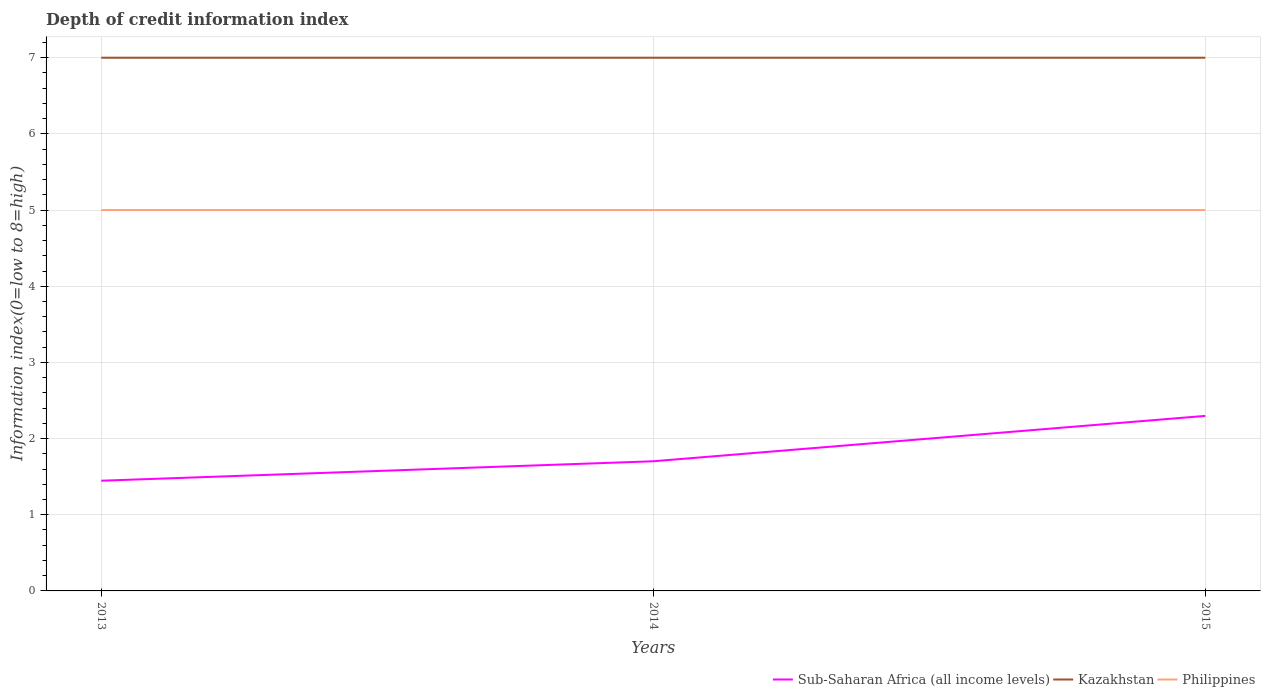How many different coloured lines are there?
Make the answer very short. 3. Does the line corresponding to Kazakhstan intersect with the line corresponding to Sub-Saharan Africa (all income levels)?
Provide a short and direct response. No. Is the number of lines equal to the number of legend labels?
Give a very brief answer. Yes. Across all years, what is the maximum information index in Philippines?
Your answer should be very brief. 5. In which year was the information index in Kazakhstan maximum?
Your answer should be compact. 2013. What is the difference between the highest and the second highest information index in Philippines?
Your answer should be very brief. 0. What is the difference between the highest and the lowest information index in Sub-Saharan Africa (all income levels)?
Your answer should be very brief. 1. What is the difference between two consecutive major ticks on the Y-axis?
Provide a short and direct response. 1. Does the graph contain any zero values?
Offer a terse response. No. Does the graph contain grids?
Give a very brief answer. Yes. What is the title of the graph?
Offer a terse response. Depth of credit information index. What is the label or title of the Y-axis?
Offer a very short reply. Information index(0=low to 8=high). What is the Information index(0=low to 8=high) of Sub-Saharan Africa (all income levels) in 2013?
Give a very brief answer. 1.45. What is the Information index(0=low to 8=high) of Kazakhstan in 2013?
Your answer should be compact. 7. What is the Information index(0=low to 8=high) of Sub-Saharan Africa (all income levels) in 2014?
Ensure brevity in your answer.  1.7. What is the Information index(0=low to 8=high) in Sub-Saharan Africa (all income levels) in 2015?
Make the answer very short. 2.3. What is the Information index(0=low to 8=high) in Kazakhstan in 2015?
Make the answer very short. 7. Across all years, what is the maximum Information index(0=low to 8=high) of Sub-Saharan Africa (all income levels)?
Make the answer very short. 2.3. Across all years, what is the maximum Information index(0=low to 8=high) of Kazakhstan?
Your response must be concise. 7. Across all years, what is the maximum Information index(0=low to 8=high) of Philippines?
Provide a short and direct response. 5. Across all years, what is the minimum Information index(0=low to 8=high) in Sub-Saharan Africa (all income levels)?
Offer a very short reply. 1.45. Across all years, what is the minimum Information index(0=low to 8=high) of Kazakhstan?
Keep it short and to the point. 7. Across all years, what is the minimum Information index(0=low to 8=high) of Philippines?
Your answer should be very brief. 5. What is the total Information index(0=low to 8=high) of Sub-Saharan Africa (all income levels) in the graph?
Ensure brevity in your answer.  5.45. What is the total Information index(0=low to 8=high) in Philippines in the graph?
Ensure brevity in your answer.  15. What is the difference between the Information index(0=low to 8=high) of Sub-Saharan Africa (all income levels) in 2013 and that in 2014?
Offer a terse response. -0.26. What is the difference between the Information index(0=low to 8=high) in Kazakhstan in 2013 and that in 2014?
Your answer should be very brief. 0. What is the difference between the Information index(0=low to 8=high) of Philippines in 2013 and that in 2014?
Your answer should be very brief. 0. What is the difference between the Information index(0=low to 8=high) of Sub-Saharan Africa (all income levels) in 2013 and that in 2015?
Ensure brevity in your answer.  -0.85. What is the difference between the Information index(0=low to 8=high) of Sub-Saharan Africa (all income levels) in 2014 and that in 2015?
Ensure brevity in your answer.  -0.6. What is the difference between the Information index(0=low to 8=high) in Philippines in 2014 and that in 2015?
Your response must be concise. 0. What is the difference between the Information index(0=low to 8=high) in Sub-Saharan Africa (all income levels) in 2013 and the Information index(0=low to 8=high) in Kazakhstan in 2014?
Provide a short and direct response. -5.55. What is the difference between the Information index(0=low to 8=high) of Sub-Saharan Africa (all income levels) in 2013 and the Information index(0=low to 8=high) of Philippines in 2014?
Your answer should be compact. -3.55. What is the difference between the Information index(0=low to 8=high) of Sub-Saharan Africa (all income levels) in 2013 and the Information index(0=low to 8=high) of Kazakhstan in 2015?
Keep it short and to the point. -5.55. What is the difference between the Information index(0=low to 8=high) of Sub-Saharan Africa (all income levels) in 2013 and the Information index(0=low to 8=high) of Philippines in 2015?
Offer a terse response. -3.55. What is the difference between the Information index(0=low to 8=high) in Kazakhstan in 2013 and the Information index(0=low to 8=high) in Philippines in 2015?
Provide a short and direct response. 2. What is the difference between the Information index(0=low to 8=high) of Sub-Saharan Africa (all income levels) in 2014 and the Information index(0=low to 8=high) of Kazakhstan in 2015?
Your answer should be compact. -5.3. What is the difference between the Information index(0=low to 8=high) of Sub-Saharan Africa (all income levels) in 2014 and the Information index(0=low to 8=high) of Philippines in 2015?
Make the answer very short. -3.3. What is the difference between the Information index(0=low to 8=high) in Kazakhstan in 2014 and the Information index(0=low to 8=high) in Philippines in 2015?
Your response must be concise. 2. What is the average Information index(0=low to 8=high) of Sub-Saharan Africa (all income levels) per year?
Make the answer very short. 1.82. What is the average Information index(0=low to 8=high) in Kazakhstan per year?
Give a very brief answer. 7. In the year 2013, what is the difference between the Information index(0=low to 8=high) of Sub-Saharan Africa (all income levels) and Information index(0=low to 8=high) of Kazakhstan?
Provide a succinct answer. -5.55. In the year 2013, what is the difference between the Information index(0=low to 8=high) of Sub-Saharan Africa (all income levels) and Information index(0=low to 8=high) of Philippines?
Provide a succinct answer. -3.55. In the year 2014, what is the difference between the Information index(0=low to 8=high) of Sub-Saharan Africa (all income levels) and Information index(0=low to 8=high) of Kazakhstan?
Give a very brief answer. -5.3. In the year 2014, what is the difference between the Information index(0=low to 8=high) in Sub-Saharan Africa (all income levels) and Information index(0=low to 8=high) in Philippines?
Ensure brevity in your answer.  -3.3. In the year 2014, what is the difference between the Information index(0=low to 8=high) in Kazakhstan and Information index(0=low to 8=high) in Philippines?
Provide a short and direct response. 2. In the year 2015, what is the difference between the Information index(0=low to 8=high) in Sub-Saharan Africa (all income levels) and Information index(0=low to 8=high) in Kazakhstan?
Provide a succinct answer. -4.7. In the year 2015, what is the difference between the Information index(0=low to 8=high) of Sub-Saharan Africa (all income levels) and Information index(0=low to 8=high) of Philippines?
Provide a succinct answer. -2.7. In the year 2015, what is the difference between the Information index(0=low to 8=high) of Kazakhstan and Information index(0=low to 8=high) of Philippines?
Make the answer very short. 2. What is the ratio of the Information index(0=low to 8=high) of Sub-Saharan Africa (all income levels) in 2013 to that in 2014?
Your answer should be very brief. 0.85. What is the ratio of the Information index(0=low to 8=high) in Kazakhstan in 2013 to that in 2014?
Offer a very short reply. 1. What is the ratio of the Information index(0=low to 8=high) of Sub-Saharan Africa (all income levels) in 2013 to that in 2015?
Ensure brevity in your answer.  0.63. What is the ratio of the Information index(0=low to 8=high) in Kazakhstan in 2013 to that in 2015?
Your response must be concise. 1. What is the ratio of the Information index(0=low to 8=high) in Sub-Saharan Africa (all income levels) in 2014 to that in 2015?
Your response must be concise. 0.74. What is the ratio of the Information index(0=low to 8=high) of Kazakhstan in 2014 to that in 2015?
Ensure brevity in your answer.  1. What is the ratio of the Information index(0=low to 8=high) of Philippines in 2014 to that in 2015?
Make the answer very short. 1. What is the difference between the highest and the second highest Information index(0=low to 8=high) of Sub-Saharan Africa (all income levels)?
Offer a very short reply. 0.6. What is the difference between the highest and the lowest Information index(0=low to 8=high) of Sub-Saharan Africa (all income levels)?
Your answer should be compact. 0.85. What is the difference between the highest and the lowest Information index(0=low to 8=high) of Philippines?
Ensure brevity in your answer.  0. 